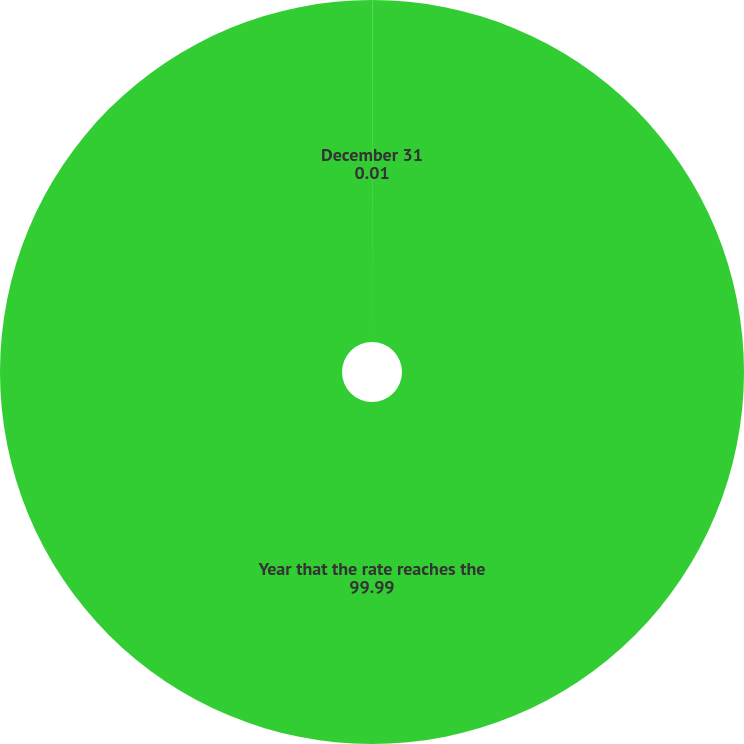Convert chart to OTSL. <chart><loc_0><loc_0><loc_500><loc_500><pie_chart><fcel>December 31<fcel>Year that the rate reaches the<nl><fcel>0.01%<fcel>99.99%<nl></chart> 